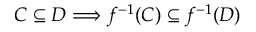<formula> <loc_0><loc_0><loc_500><loc_500>C \subseteq D \Longrightarrow f ^ { - 1 } ( C ) \subseteq f ^ { - 1 } ( D )</formula> 